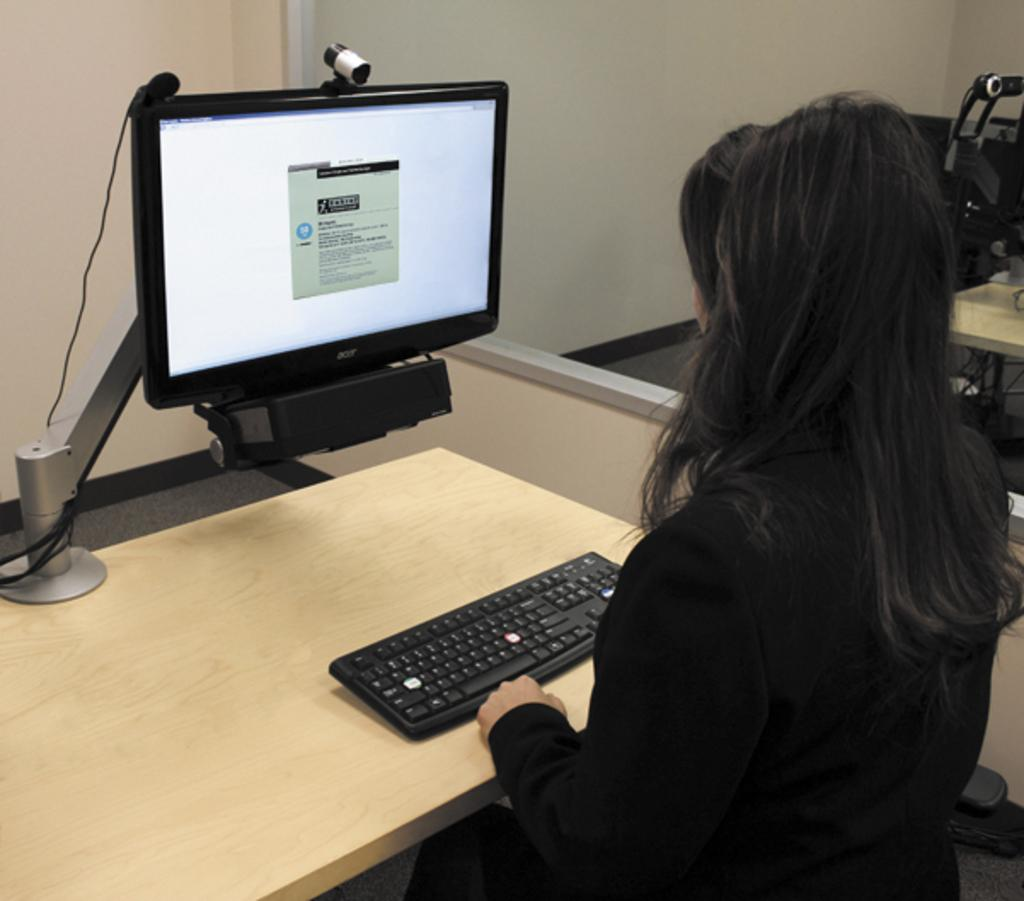What electronic device is visible in the image? There is a computer in the image. What is used to input data into the computer? There is a keyboard in the image. Where are the computer and keyboard located? The computer and keyboard are on a table. Who is present in the image? There is a woman sitting in a chair in the image. What type of air can be seen flowing through the computer in the image? There is no air flowing through the computer in the image. Can you tell me how many friends are present in the image? There is no mention of friends in the image; only a woman sitting in a chair is present. 